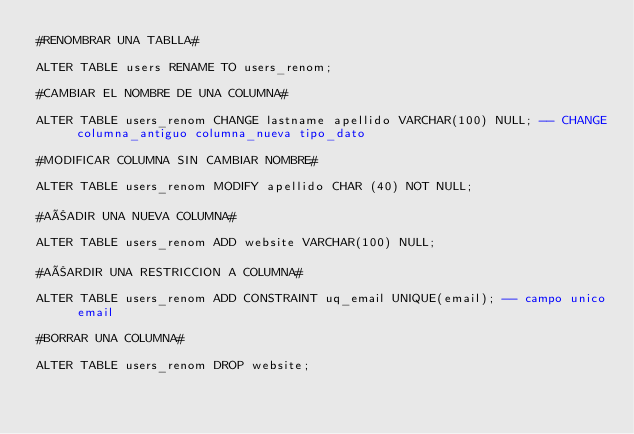Convert code to text. <code><loc_0><loc_0><loc_500><loc_500><_SQL_>#RENOMBRAR UNA TABLLA#

ALTER TABLE users RENAME TO users_renom;

#CAMBIAR EL NOMBRE DE UNA COLUMNA#

ALTER TABLE users_renom CHANGE lastname apellido VARCHAR(100) NULL; -- CHANGE columna_antiguo columna_nueva tipo_dato

#MODIFICAR COLUMNA SIN CAMBIAR NOMBRE#

ALTER TABLE users_renom MODIFY apellido CHAR (40) NOT NULL;

#AÑADIR UNA NUEVA COLUMNA#

ALTER TABLE users_renom ADD website VARCHAR(100) NULL;

#AÑARDIR UNA RESTRICCION A COLUMNA#

ALTER TABLE users_renom ADD CONSTRAINT uq_email UNIQUE(email); -- campo unico email

#BORRAR UNA COLUMNA#

ALTER TABLE users_renom DROP website;</code> 